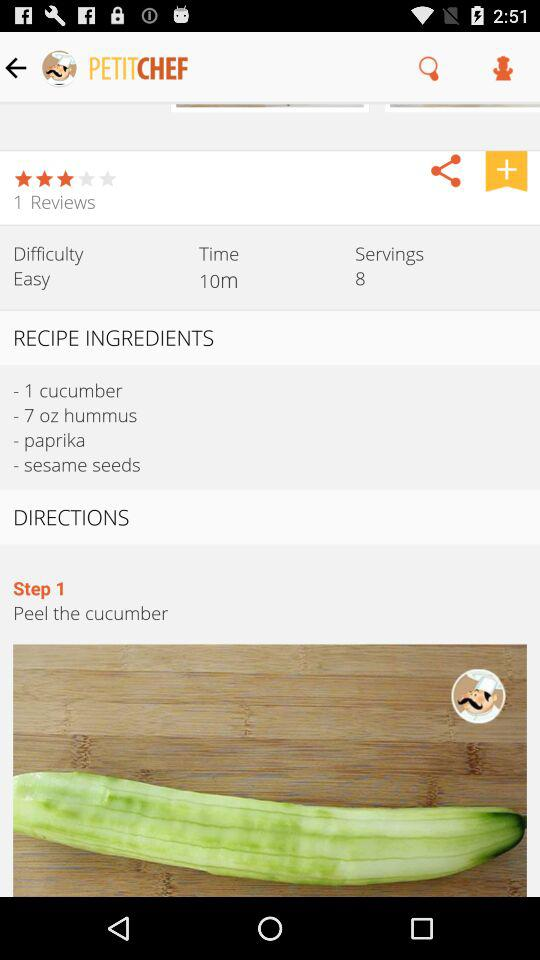How many people can the dish serve? The dish can serve 8 people. 